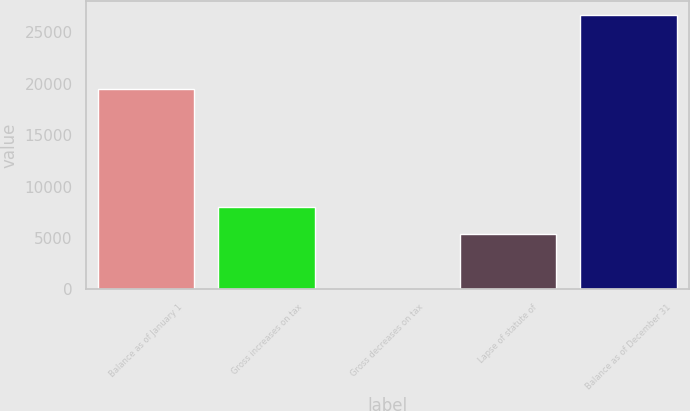Convert chart to OTSL. <chart><loc_0><loc_0><loc_500><loc_500><bar_chart><fcel>Balance as of January 1<fcel>Gross increases on tax<fcel>Gross decreases on tax<fcel>Lapse of statute of<fcel>Balance as of December 31<nl><fcel>19493<fcel>8036.1<fcel>18<fcel>5363.4<fcel>26745<nl></chart> 